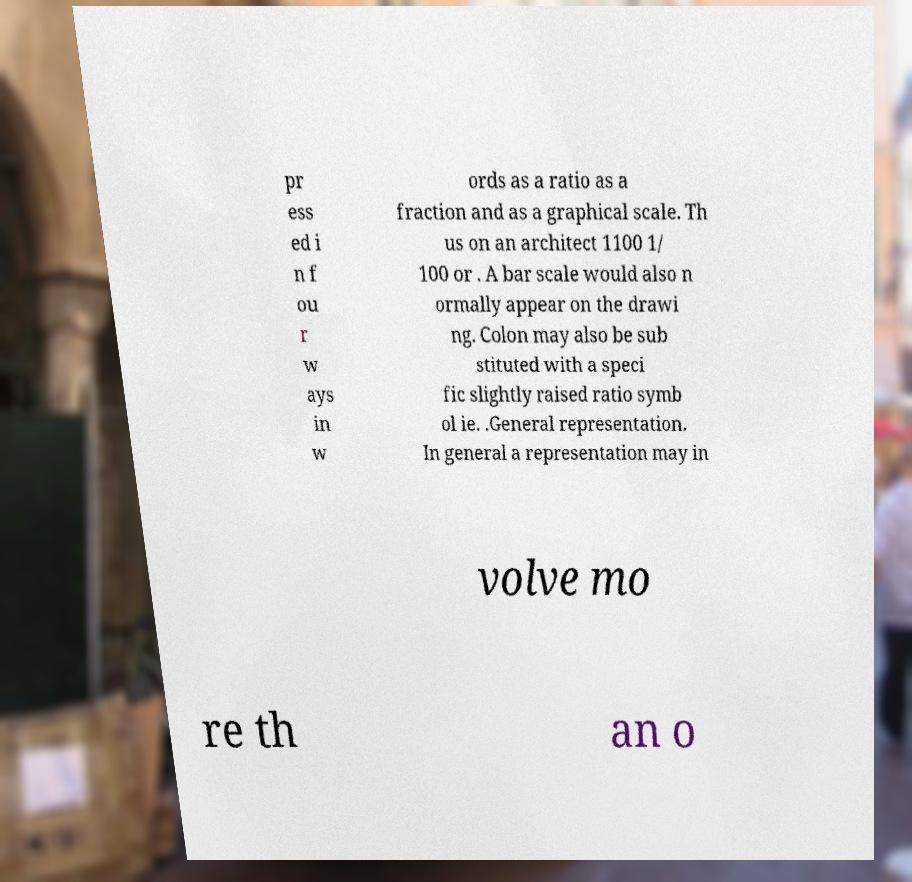Please identify and transcribe the text found in this image. pr ess ed i n f ou r w ays in w ords as a ratio as a fraction and as a graphical scale. Th us on an architect 1100 1/ 100 or . A bar scale would also n ormally appear on the drawi ng. Colon may also be sub stituted with a speci fic slightly raised ratio symb ol ie. .General representation. In general a representation may in volve mo re th an o 